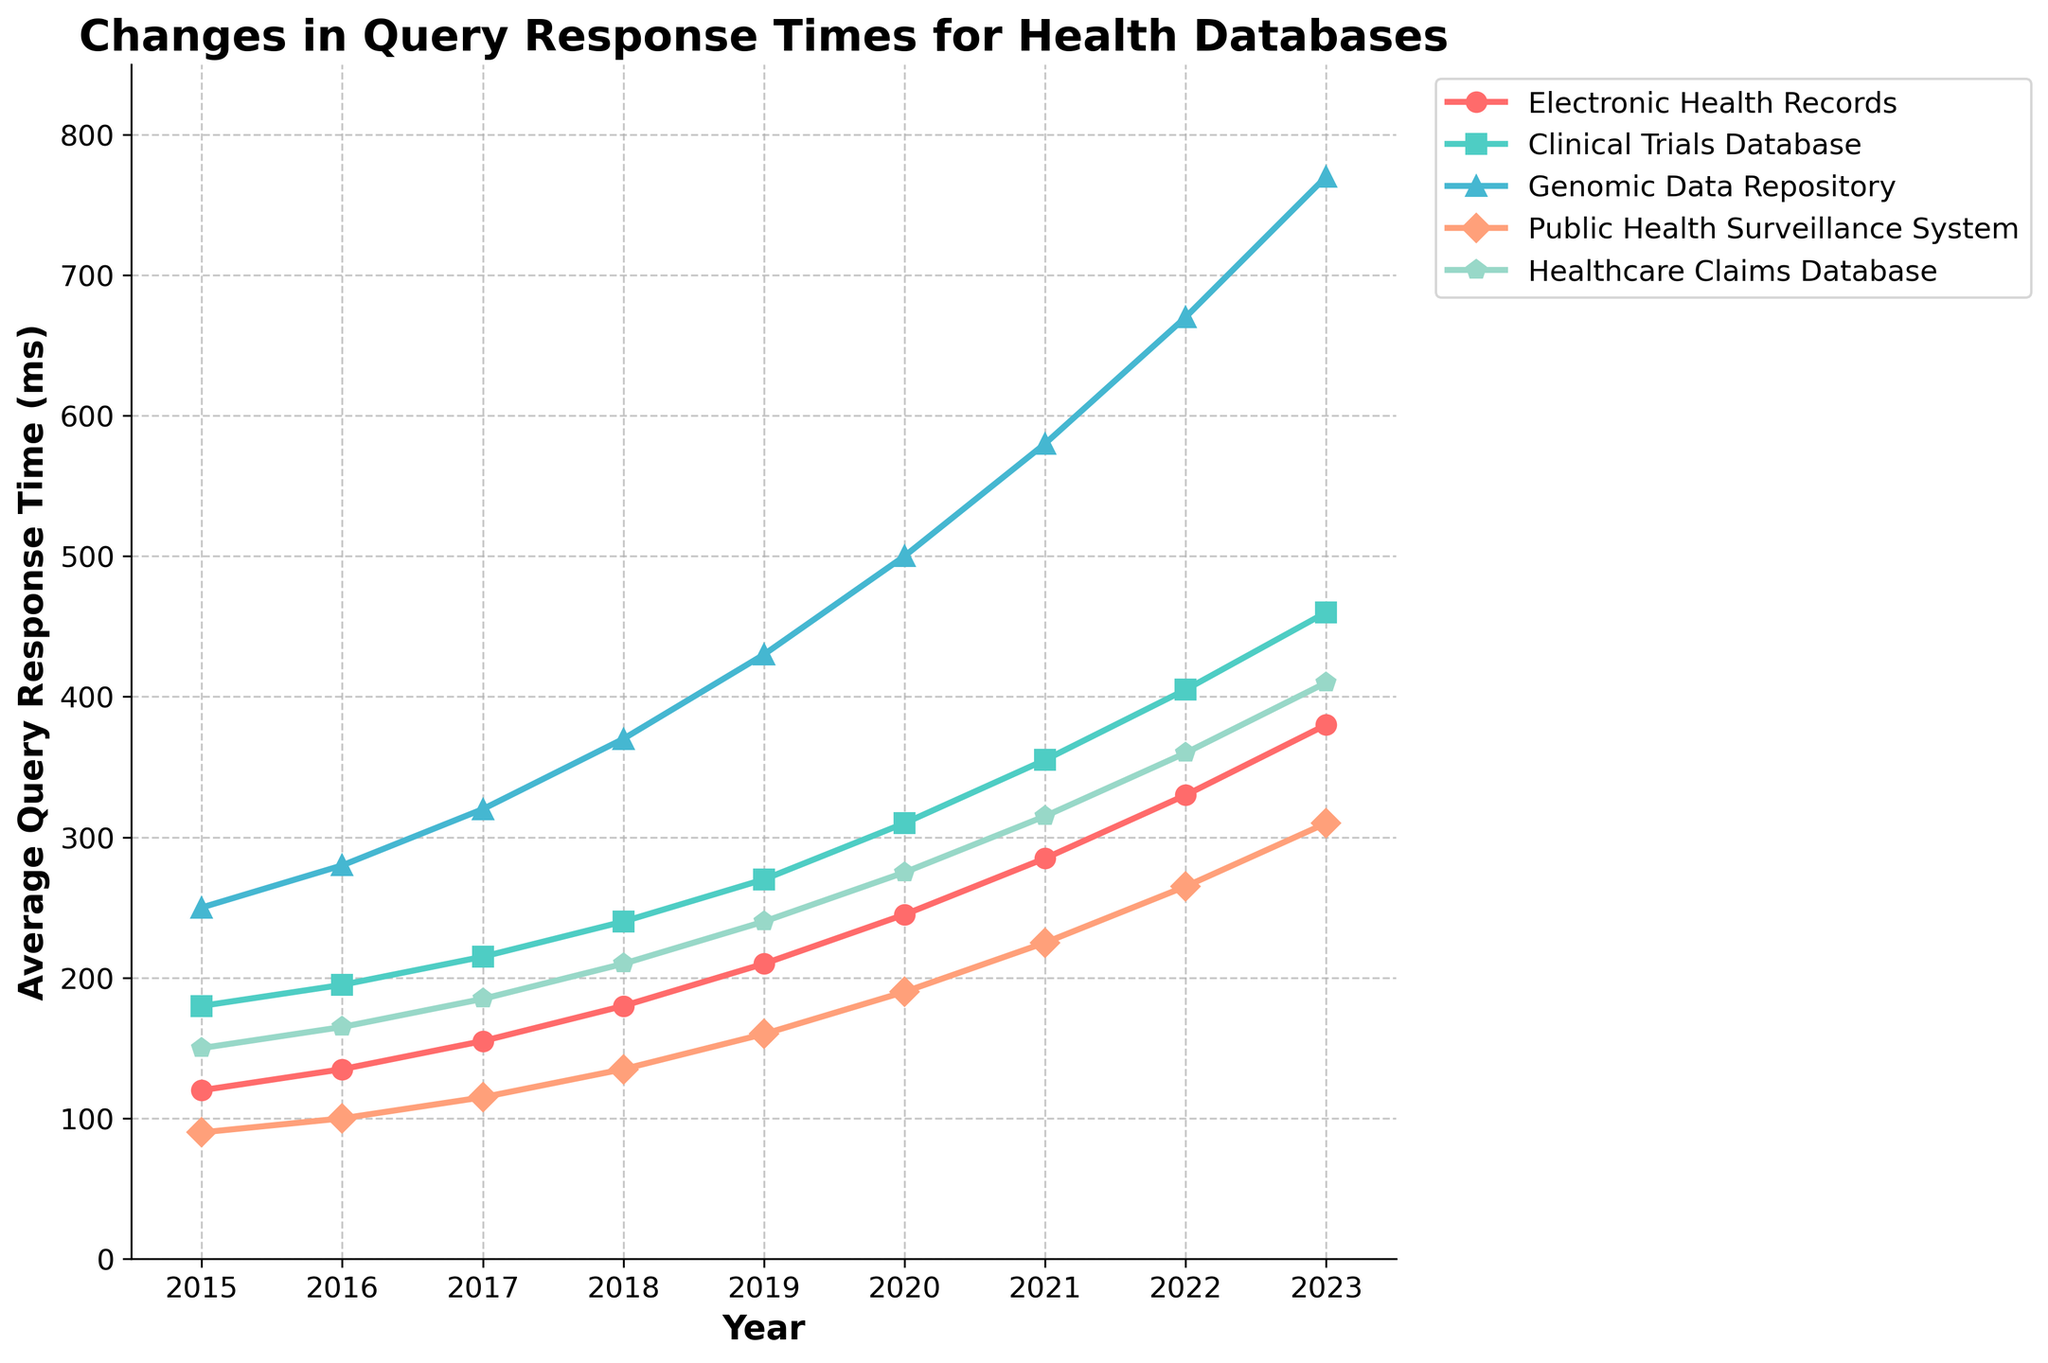How has the average query response time for the Electronic Health Records database changed from 2015 to 2023? The Electronic Health Records database had an average query response time of 120ms in 2015 and increased to 380ms in 2023. This change is calculated by subtracting 120ms from 380ms (380 - 120).
Answer: 260ms Which database had the highest average query response time in 2021? By looking at the plotted data for the year 2021, the Genomic Data Repository had the highest average query response time. All other databases had response times lower than 580ms.
Answer: Genomic Data Repository Which database showed the smallest increase in average query response time from 2015 to 2023? By comparing the starting and ending points for each database, the Public Health Surveillance System showed the smallest increase, starting at 90ms in 2015 and increasing to 310ms in 2023. The increase is 310ms - 90ms = 220ms.
Answer: Public Health Surveillance System What is the difference in average query response time between the Genomic Data Repository and the Healthcare Claims Database in 2023? In 2023, the Genomic Data Repository had a response time of 770ms while the Healthcare Claims Database had 410ms. Their difference is 770ms - 410ms.
Answer: 360ms Between which consecutive years did the Clinical Trials Database experience the largest increase in query response times? The Clinical Trials Database response times between consecutive years increased as follows: 2015-2016 (15ms), 2016-2017 (20ms), 2017-2018 (25ms), 2018-2019 (30ms), 2019-2020 (40ms), 2020-2021 (45ms), 2021-2022 (50ms), and 2022-2023 (55ms). The largest increase happened between 2022 and 2023.
Answer: 2022-2023 What color represents the Electronic Health Records database line in the plot? By looking at the plot, the line representing the Electronic Health Records database is identified by its color, which is red.
Answer: Red How does the average query response time for Public Health Surveillance System in 2020 compare with that of Electronic Health Records in the same year? In 2020, the query response time for Public Health Surveillance System was 190ms, while for Electronic Health Records it was 245ms. Therefore, the Public Health Surveillance System had a lower response time.
Answer: Lower What is the combined average query response time of the Clinical Trials Database and the Genomic Data Repository in 2018? In 2018, the Clinical Trials Database response time was 240ms and the Genomic Data Repository was 370ms. Their combined average is calculated as (240ms + 370ms) / 2.
Answer: 305ms Which database shows a more consistent increase over the years, Electronic Health Records or Genomic Data Repository? The Electronic Health Records database has a more consistent, linear progression of increases each year, compared to the more varied increments in the Genomic Data Repository, which shows a sharp increase after 2019.
Answer: Electronic Health Records During which year did the Healthcare Claims Database surpass 300ms in average query response time? By examining the plotted data points, the Healthcare Claims Database surpassed 300ms in 2021 when it reached 315ms.
Answer: 2021 